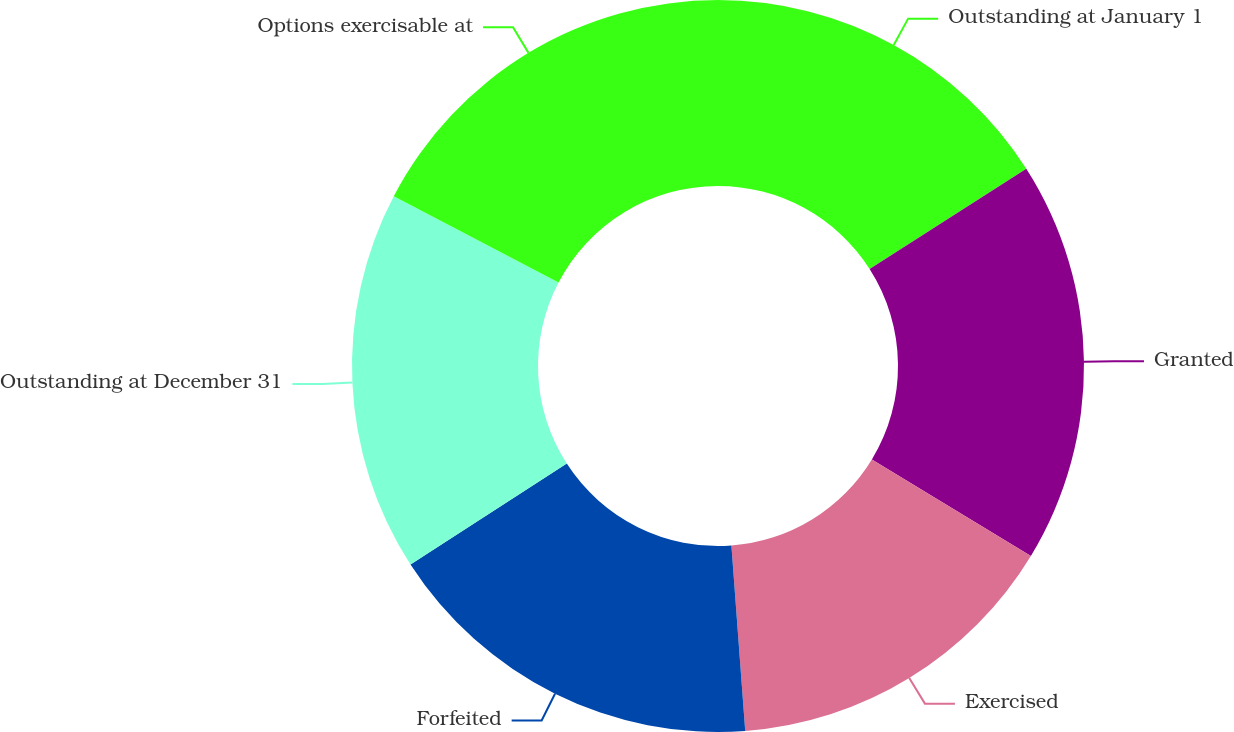Convert chart. <chart><loc_0><loc_0><loc_500><loc_500><pie_chart><fcel>Outstanding at January 1<fcel>Granted<fcel>Exercised<fcel>Forfeited<fcel>Outstanding at December 31<fcel>Options exercisable at<nl><fcel>15.94%<fcel>17.74%<fcel>15.13%<fcel>17.06%<fcel>16.8%<fcel>17.32%<nl></chart> 